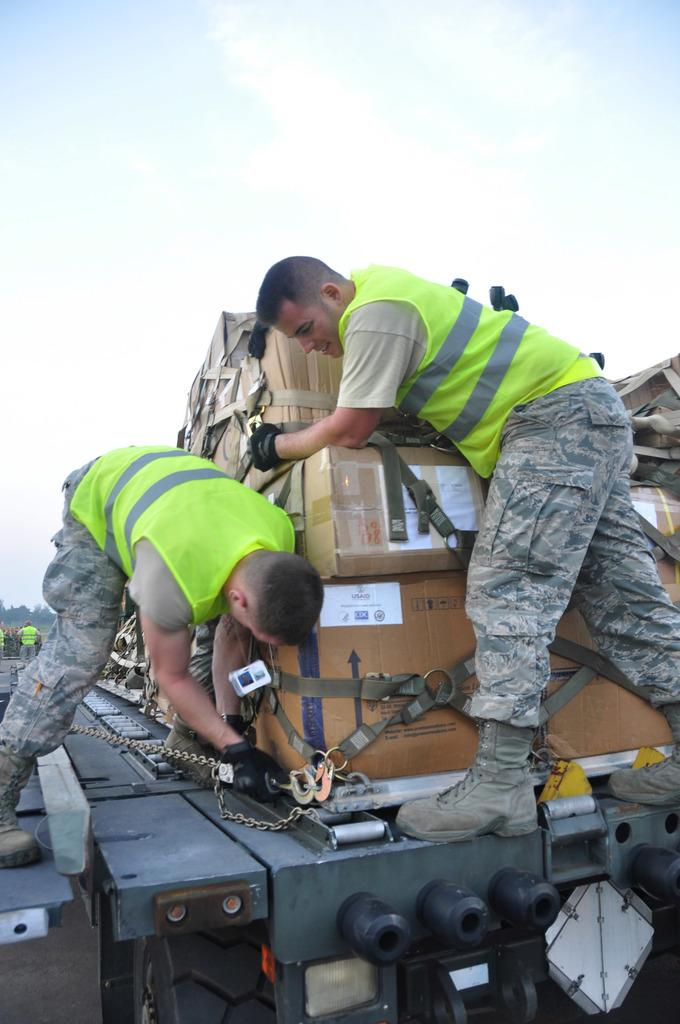How many military men are in the image? There are two military men in the image. What are the military men wearing? The military men are wearing green safety jackets. What are the military men doing in the image? The military men are loading brown carton boxes onto a truck. What can be seen in the sky in the image? The sky is visible in the image, and clouds are present. What type of swimsuit is the manager wearing in the image? There is no manager or swimsuit present in the image. How does the brain of the military men affect their performance in the image? The image does not provide information about the military men's brains, so it is impossible to determine how their brains affect their performance. 